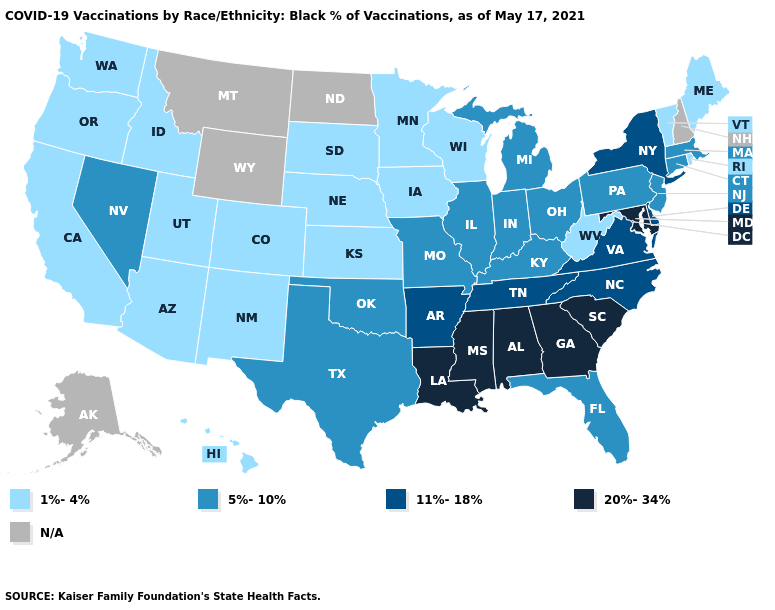What is the lowest value in the West?
Write a very short answer. 1%-4%. Which states have the highest value in the USA?
Short answer required. Alabama, Georgia, Louisiana, Maryland, Mississippi, South Carolina. Name the states that have a value in the range N/A?
Short answer required. Alaska, Montana, New Hampshire, North Dakota, Wyoming. What is the highest value in states that border Delaware?
Concise answer only. 20%-34%. What is the lowest value in the MidWest?
Be succinct. 1%-4%. What is the value of Kentucky?
Quick response, please. 5%-10%. What is the value of Maine?
Give a very brief answer. 1%-4%. What is the highest value in the West ?
Quick response, please. 5%-10%. Name the states that have a value in the range N/A?
Short answer required. Alaska, Montana, New Hampshire, North Dakota, Wyoming. What is the lowest value in the USA?
Quick response, please. 1%-4%. Name the states that have a value in the range N/A?
Short answer required. Alaska, Montana, New Hampshire, North Dakota, Wyoming. Does the map have missing data?
Concise answer only. Yes. Does Michigan have the highest value in the MidWest?
Concise answer only. Yes. Name the states that have a value in the range 20%-34%?
Short answer required. Alabama, Georgia, Louisiana, Maryland, Mississippi, South Carolina. 